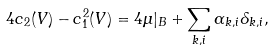<formula> <loc_0><loc_0><loc_500><loc_500>4 c _ { 2 } ( { V } ) - c _ { 1 } ^ { 2 } ( { V } ) = 4 \mu | _ { B } + \sum _ { k , i } \alpha _ { k , i } \delta _ { k , i } ,</formula> 